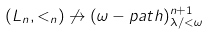<formula> <loc_0><loc_0><loc_500><loc_500>( L _ { n } , < _ { n } ) \not \rightarrow ( \omega - p a t h ) ^ { n + 1 } _ { \lambda / < \omega }</formula> 